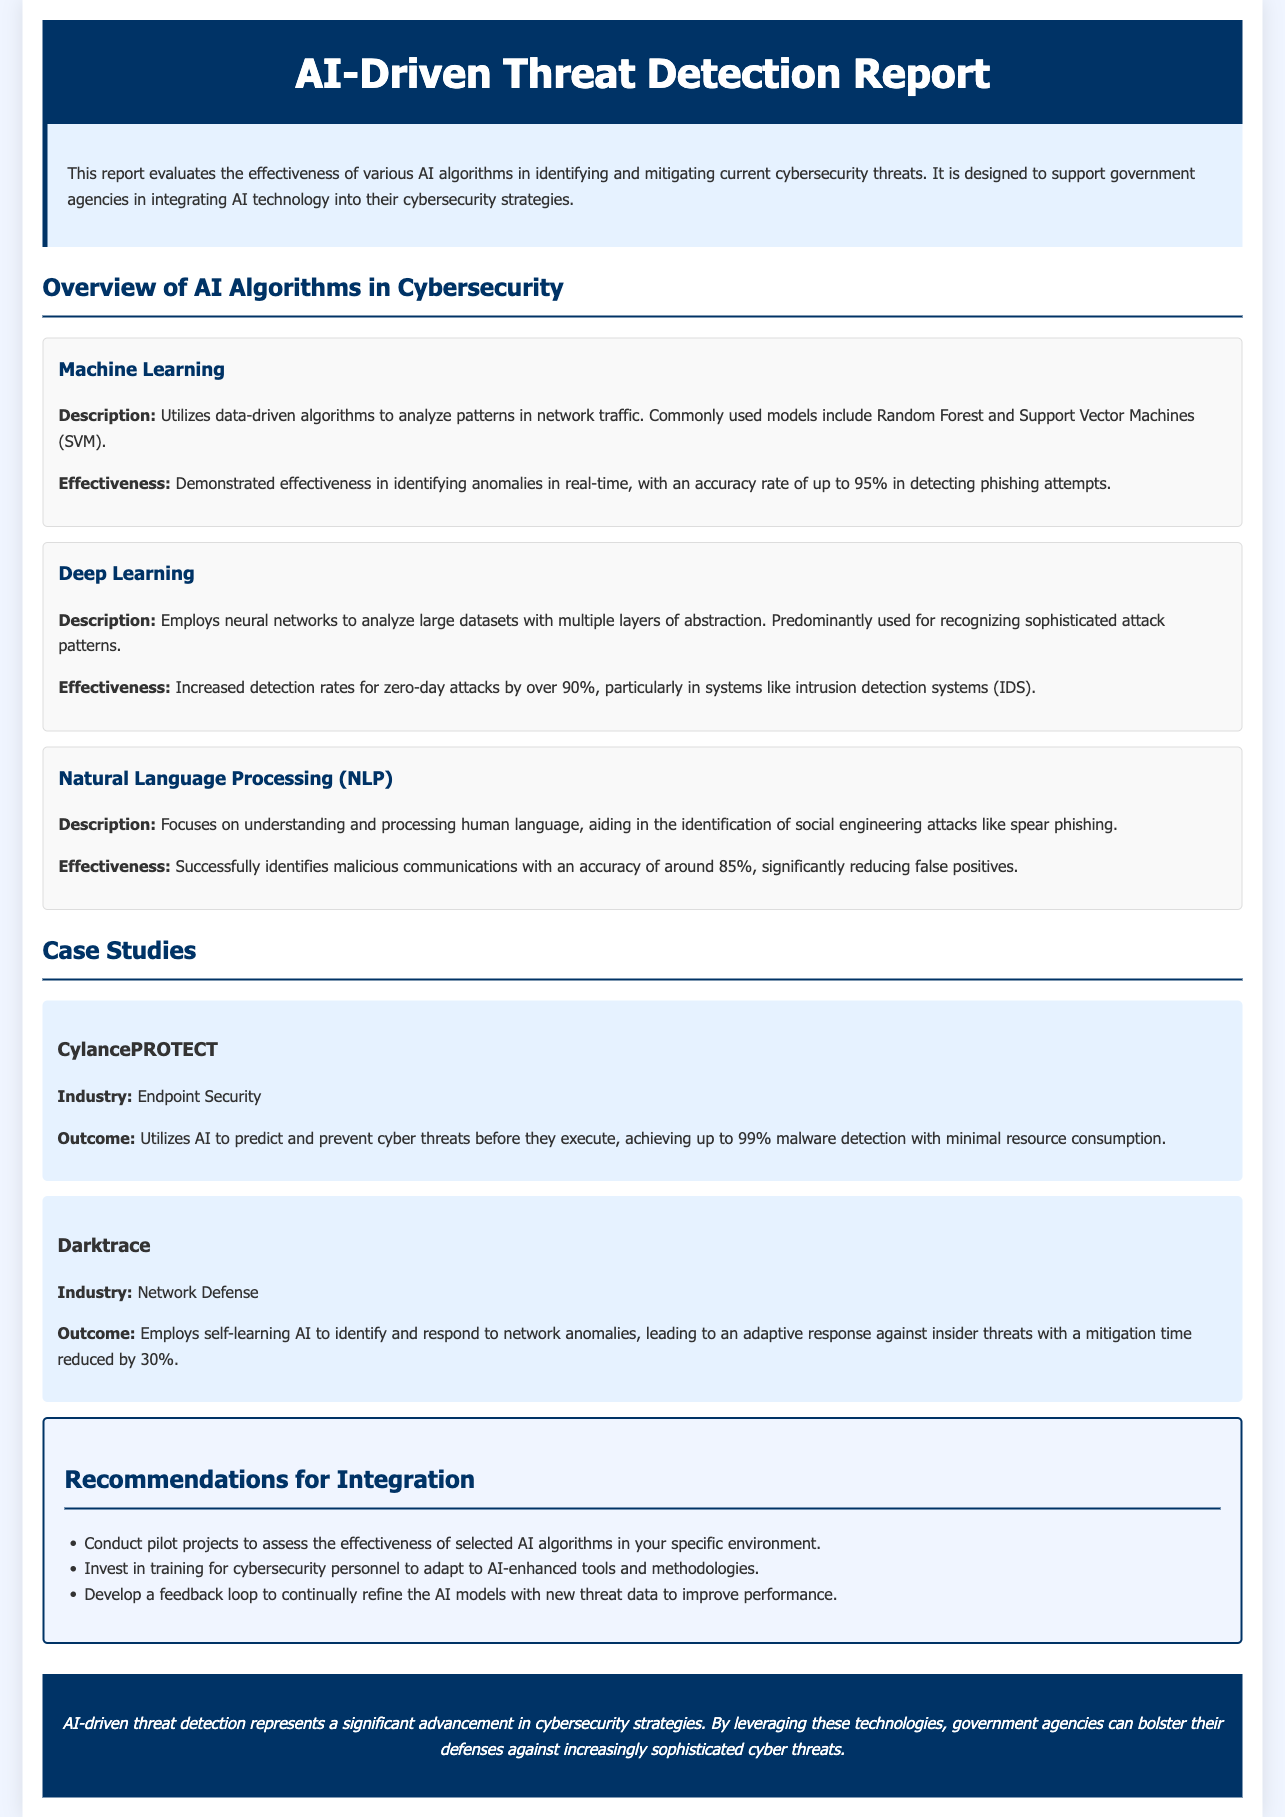What is the title of the report? The title of the report is prominently displayed at the top of the document.
Answer: AI-Driven Threat Detection Report What algorithm has an accuracy rate of up to 95% in detecting phishing attempts? The report specifies the effectiveness of Machine Learning in identifying phishing attempts.
Answer: Machine Learning What is the accuracy rate for Natural Language Processing in identifying malicious communications? The report states that NLP identifies malicious communications with a specific accuracy rate.
Answer: 85% What is the percentage increase in detection rates for zero-day attacks using Deep Learning? The report highlights the effectiveness of Deep Learning in increasing detection rates for zero-day attacks.
Answer: Over 90% Which company uses AI to predict and prevent cyber threats with up to 99% malware detection? The document provides a case study about a specific company in endpoint security.
Answer: CylancePROTECT What is the mitigation time reduction percentage achieved by Darktrace? The report describes the performance of Darktrace in terms of response time against insider threats.
Answer: 30% What is a recommended action for integrating AI into cybersecurity strategies? The recommendations section lists actionable strategies for integrating AI.
Answer: Conduct pilot projects What type of AI employs neural networks to analyze large datasets? The report categorizes different AI algorithms and specifies which uses neural networks.
Answer: Deep Learning What industry focuses on endpoint security in the case studies section? The report lists industries associated with specific case studies.
Answer: Endpoint Security 